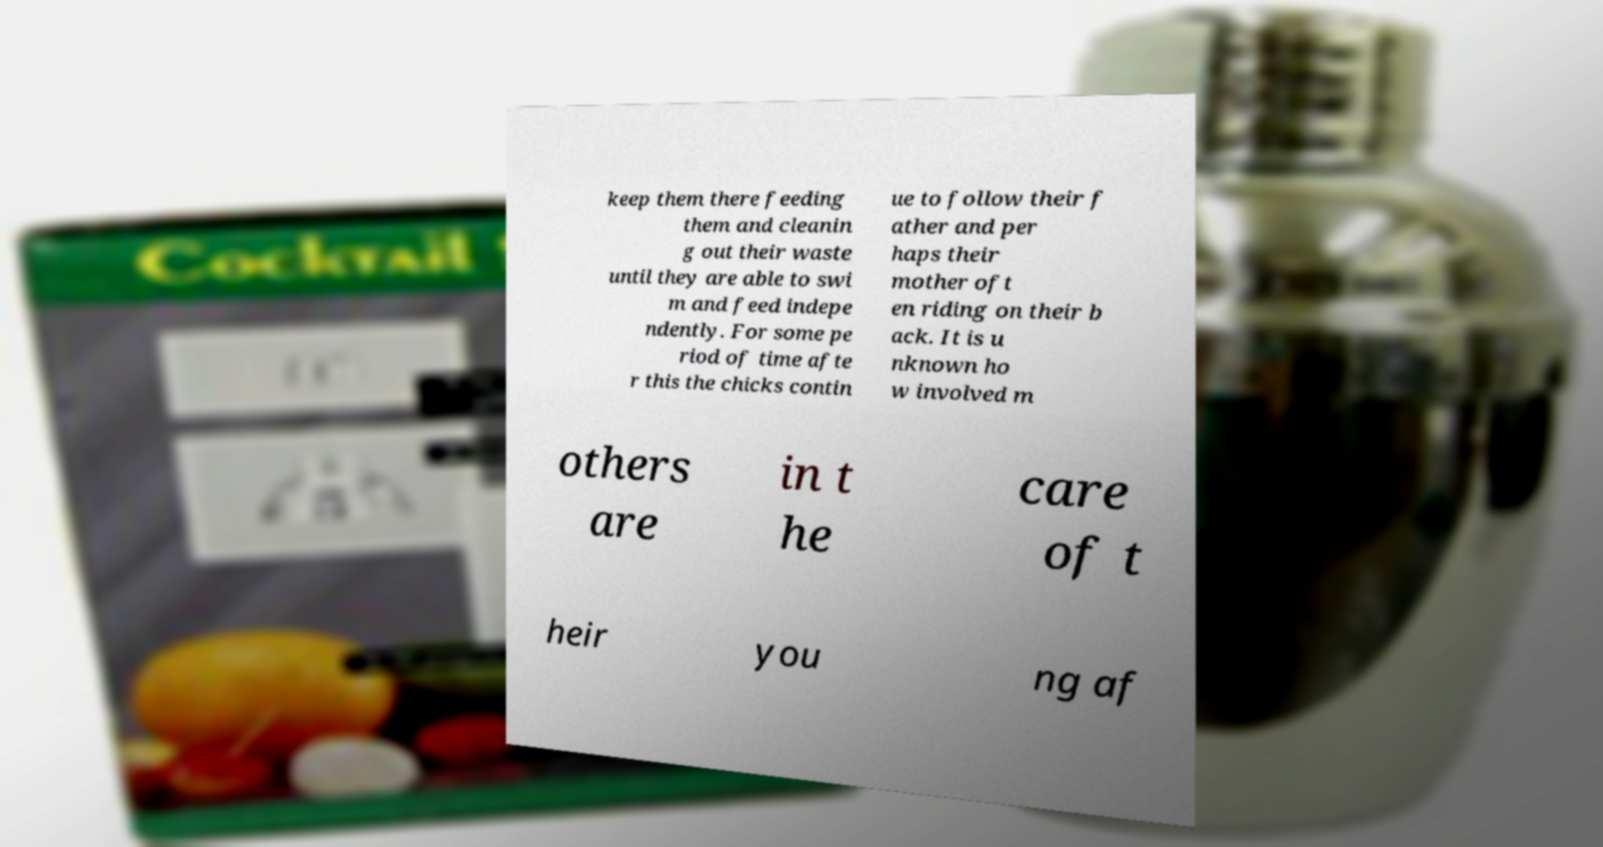What messages or text are displayed in this image? I need them in a readable, typed format. keep them there feeding them and cleanin g out their waste until they are able to swi m and feed indepe ndently. For some pe riod of time afte r this the chicks contin ue to follow their f ather and per haps their mother oft en riding on their b ack. It is u nknown ho w involved m others are in t he care of t heir you ng af 